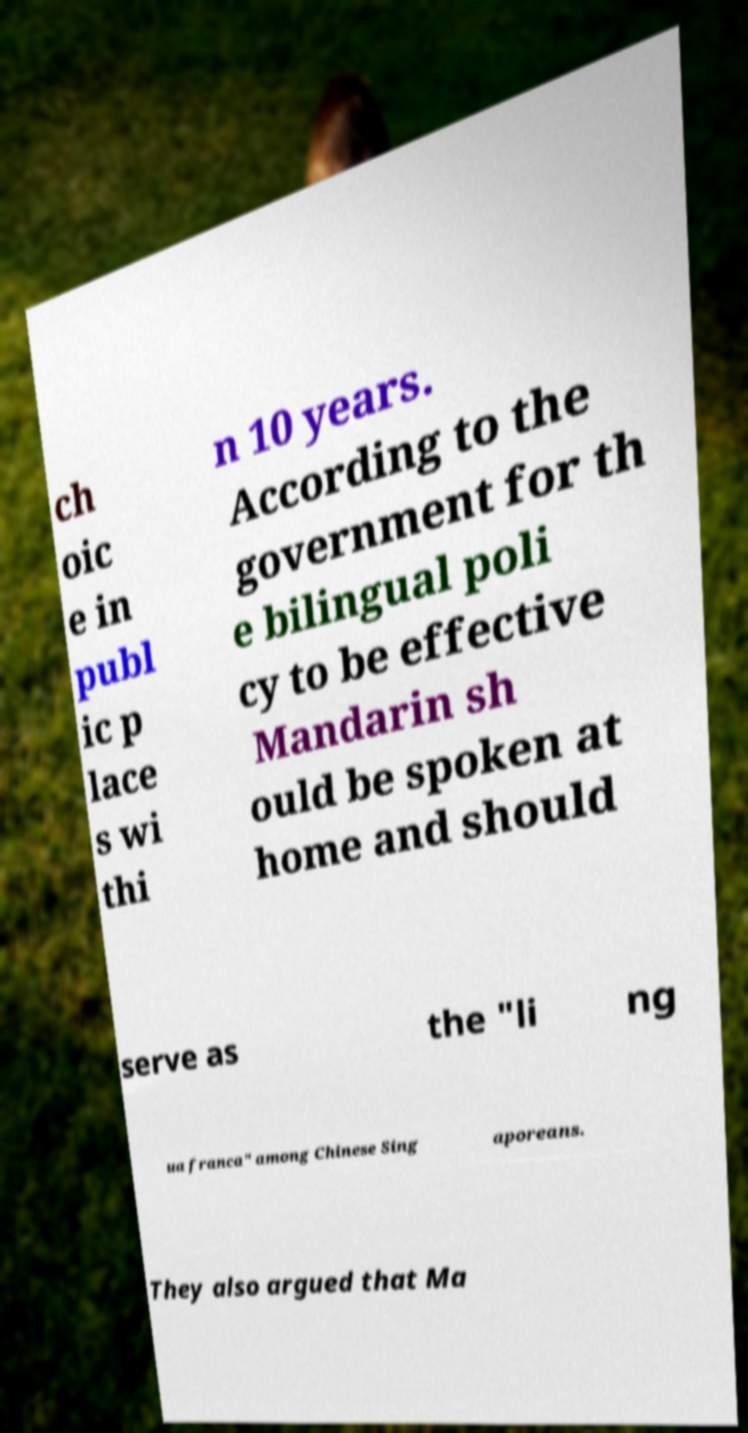There's text embedded in this image that I need extracted. Can you transcribe it verbatim? ch oic e in publ ic p lace s wi thi n 10 years. According to the government for th e bilingual poli cy to be effective Mandarin sh ould be spoken at home and should serve as the "li ng ua franca" among Chinese Sing aporeans. They also argued that Ma 